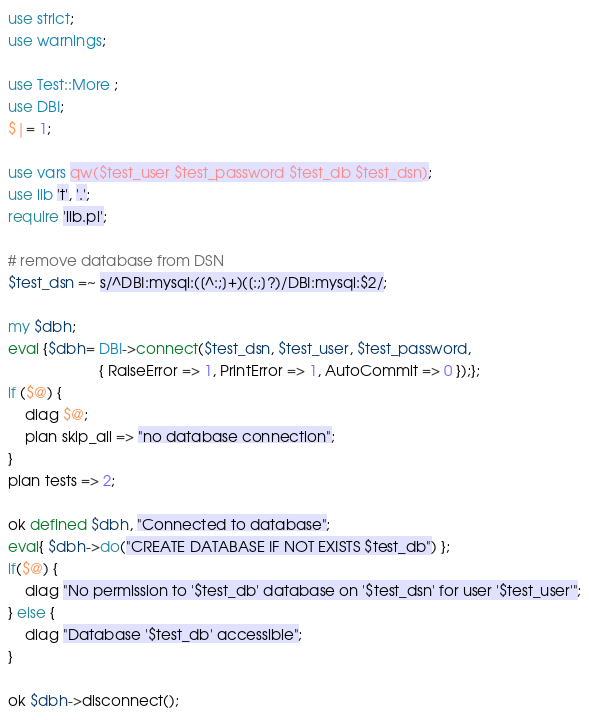<code> <loc_0><loc_0><loc_500><loc_500><_Perl_>use strict;
use warnings;

use Test::More ;
use DBI;
$|= 1;

use vars qw($test_user $test_password $test_db $test_dsn);
use lib 't', '.';
require 'lib.pl';

# remove database from DSN
$test_dsn =~ s/^DBI:mysql:([^:;]+)([:;]?)/DBI:mysql:$2/;

my $dbh;
eval {$dbh= DBI->connect($test_dsn, $test_user, $test_password,
                      { RaiseError => 1, PrintError => 1, AutoCommit => 0 });};
if ($@) {
    diag $@;
    plan skip_all => "no database connection";
}
plan tests => 2;

ok defined $dbh, "Connected to database";
eval{ $dbh->do("CREATE DATABASE IF NOT EXISTS $test_db") };
if($@) {
    diag "No permission to '$test_db' database on '$test_dsn' for user '$test_user'";
} else {
    diag "Database '$test_db' accessible";
}

ok $dbh->disconnect();
</code> 